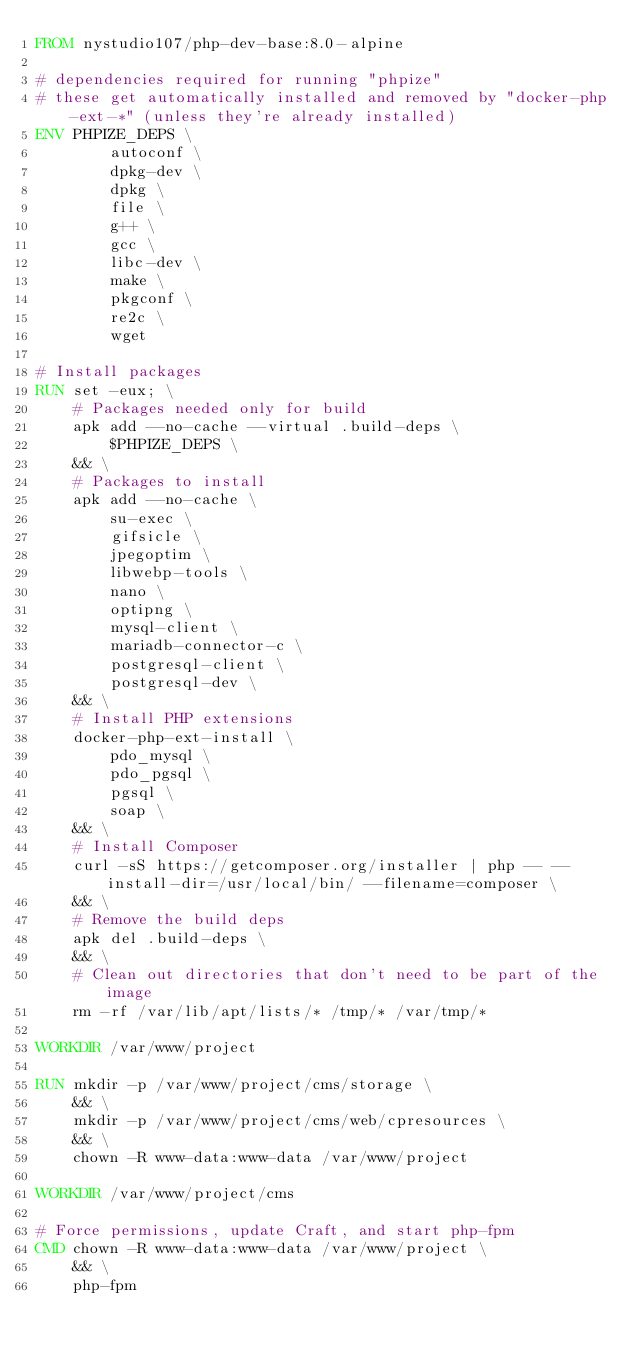Convert code to text. <code><loc_0><loc_0><loc_500><loc_500><_Dockerfile_>FROM nystudio107/php-dev-base:8.0-alpine

# dependencies required for running "phpize"
# these get automatically installed and removed by "docker-php-ext-*" (unless they're already installed)
ENV PHPIZE_DEPS \
        autoconf \
        dpkg-dev \
        dpkg \
        file \
        g++ \
        gcc \
        libc-dev \
        make \
        pkgconf \
        re2c \
        wget

# Install packages
RUN set -eux; \
    # Packages needed only for build
    apk add --no-cache --virtual .build-deps \
        $PHPIZE_DEPS \
    && \
    # Packages to install
    apk add --no-cache \
        su-exec \
        gifsicle \
        jpegoptim \
        libwebp-tools \
        nano \
        optipng \
        mysql-client \
        mariadb-connector-c \
        postgresql-client \
        postgresql-dev \
    && \
    # Install PHP extensions
    docker-php-ext-install \
        pdo_mysql \
        pdo_pgsql \
        pgsql \
        soap \
    && \
    # Install Composer
    curl -sS https://getcomposer.org/installer | php -- --install-dir=/usr/local/bin/ --filename=composer \
    && \
    # Remove the build deps
    apk del .build-deps \
    && \
    # Clean out directories that don't need to be part of the image
    rm -rf /var/lib/apt/lists/* /tmp/* /var/tmp/*

WORKDIR /var/www/project

RUN mkdir -p /var/www/project/cms/storage \
    && \
    mkdir -p /var/www/project/cms/web/cpresources \
    && \
    chown -R www-data:www-data /var/www/project

WORKDIR /var/www/project/cms

# Force permissions, update Craft, and start php-fpm
CMD chown -R www-data:www-data /var/www/project \
    && \
    php-fpm
</code> 